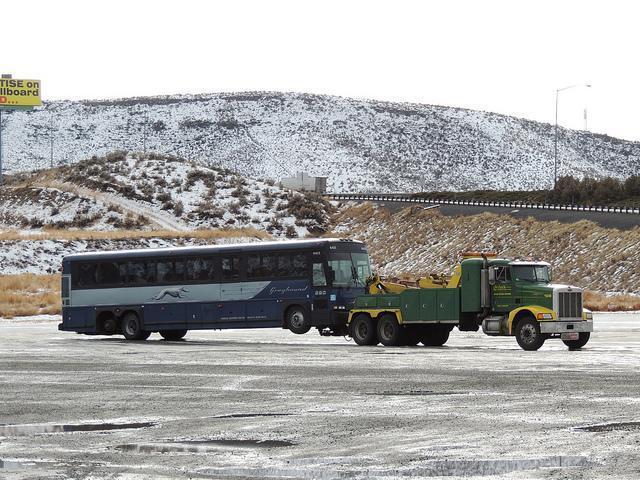How many trucks can you see?
Give a very brief answer. 1. How many people are wearing purple shirt?
Give a very brief answer. 0. 